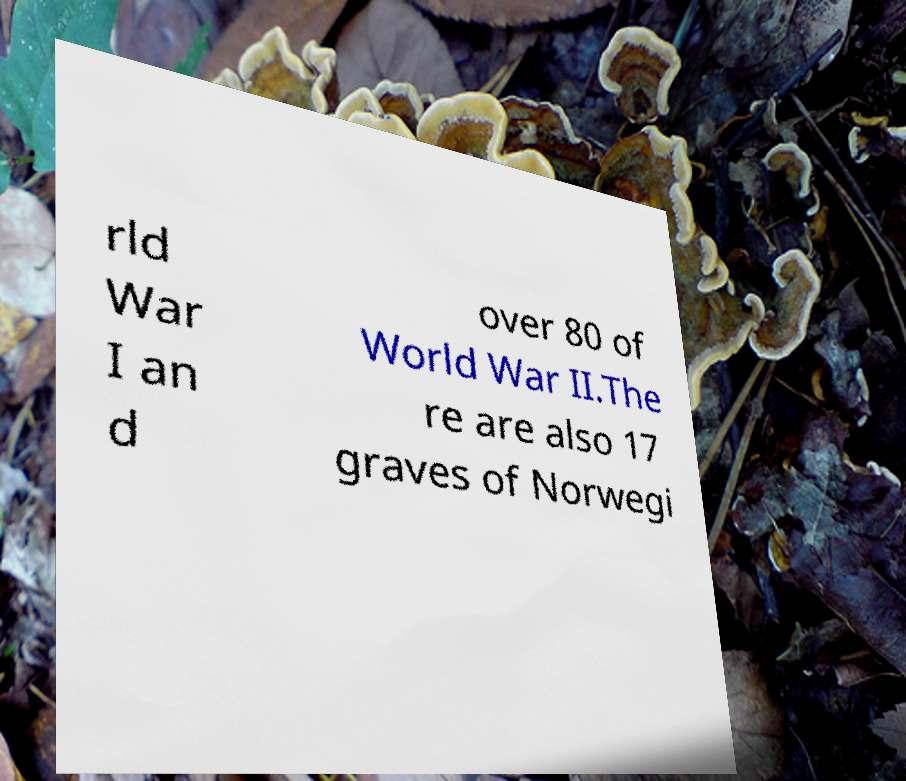Could you extract and type out the text from this image? rld War I an d over 80 of World War II.The re are also 17 graves of Norwegi 